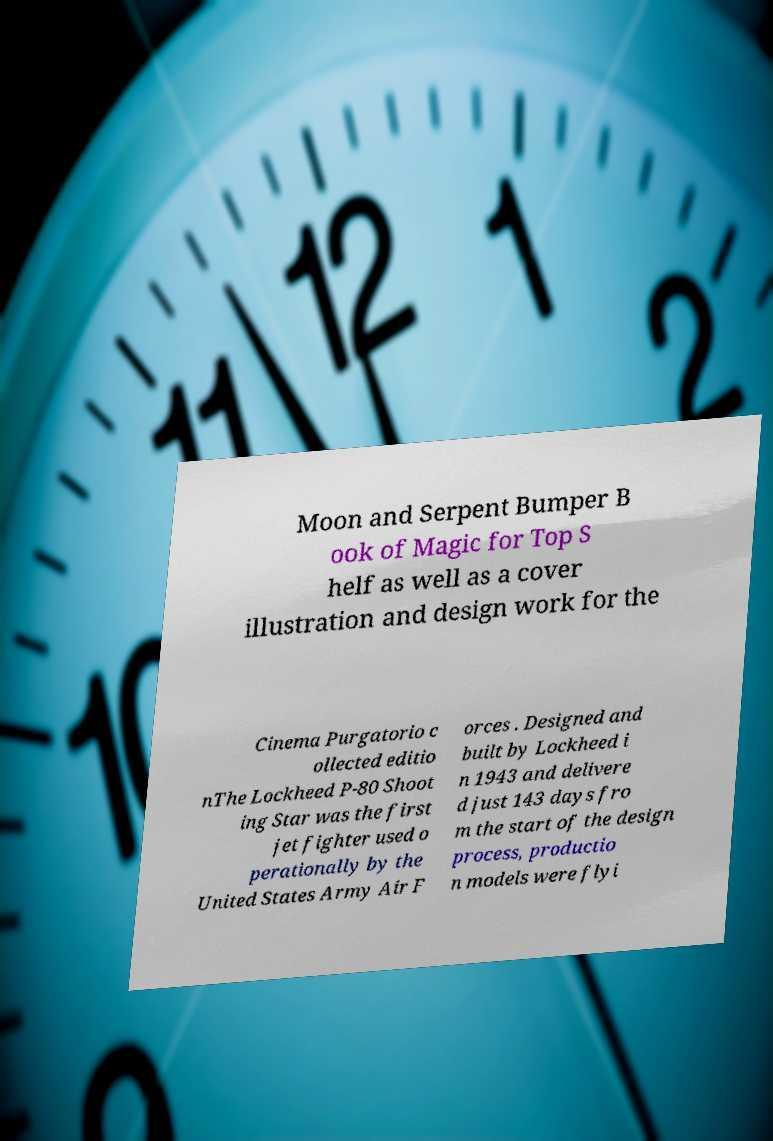There's text embedded in this image that I need extracted. Can you transcribe it verbatim? Moon and Serpent Bumper B ook of Magic for Top S helf as well as a cover illustration and design work for the Cinema Purgatorio c ollected editio nThe Lockheed P-80 Shoot ing Star was the first jet fighter used o perationally by the United States Army Air F orces . Designed and built by Lockheed i n 1943 and delivere d just 143 days fro m the start of the design process, productio n models were flyi 